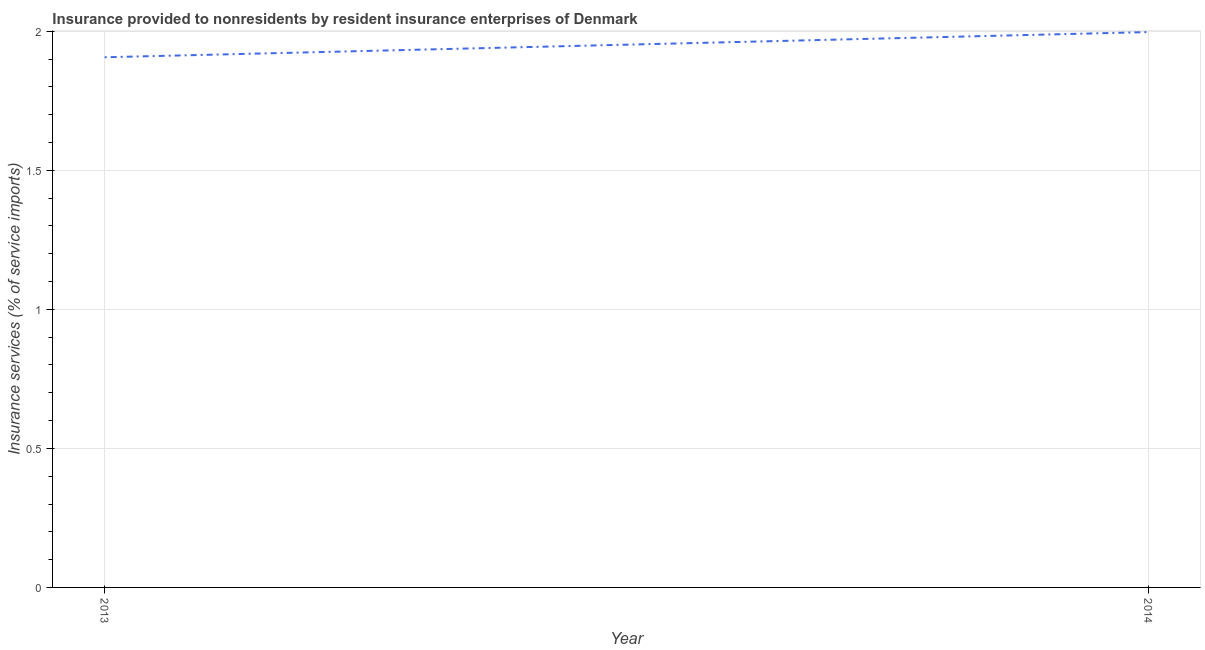What is the insurance and financial services in 2013?
Give a very brief answer. 1.91. Across all years, what is the maximum insurance and financial services?
Your response must be concise. 2. Across all years, what is the minimum insurance and financial services?
Your answer should be very brief. 1.91. What is the sum of the insurance and financial services?
Your answer should be very brief. 3.9. What is the difference between the insurance and financial services in 2013 and 2014?
Give a very brief answer. -0.09. What is the average insurance and financial services per year?
Offer a very short reply. 1.95. What is the median insurance and financial services?
Offer a very short reply. 1.95. Do a majority of the years between 2013 and 2014 (inclusive) have insurance and financial services greater than 0.30000000000000004 %?
Your answer should be very brief. Yes. What is the ratio of the insurance and financial services in 2013 to that in 2014?
Provide a short and direct response. 0.95. Is the insurance and financial services in 2013 less than that in 2014?
Give a very brief answer. Yes. How many years are there in the graph?
Keep it short and to the point. 2. What is the title of the graph?
Your answer should be compact. Insurance provided to nonresidents by resident insurance enterprises of Denmark. What is the label or title of the Y-axis?
Provide a short and direct response. Insurance services (% of service imports). What is the Insurance services (% of service imports) of 2013?
Provide a succinct answer. 1.91. What is the Insurance services (% of service imports) in 2014?
Offer a terse response. 2. What is the difference between the Insurance services (% of service imports) in 2013 and 2014?
Your response must be concise. -0.09. What is the ratio of the Insurance services (% of service imports) in 2013 to that in 2014?
Your answer should be compact. 0.95. 